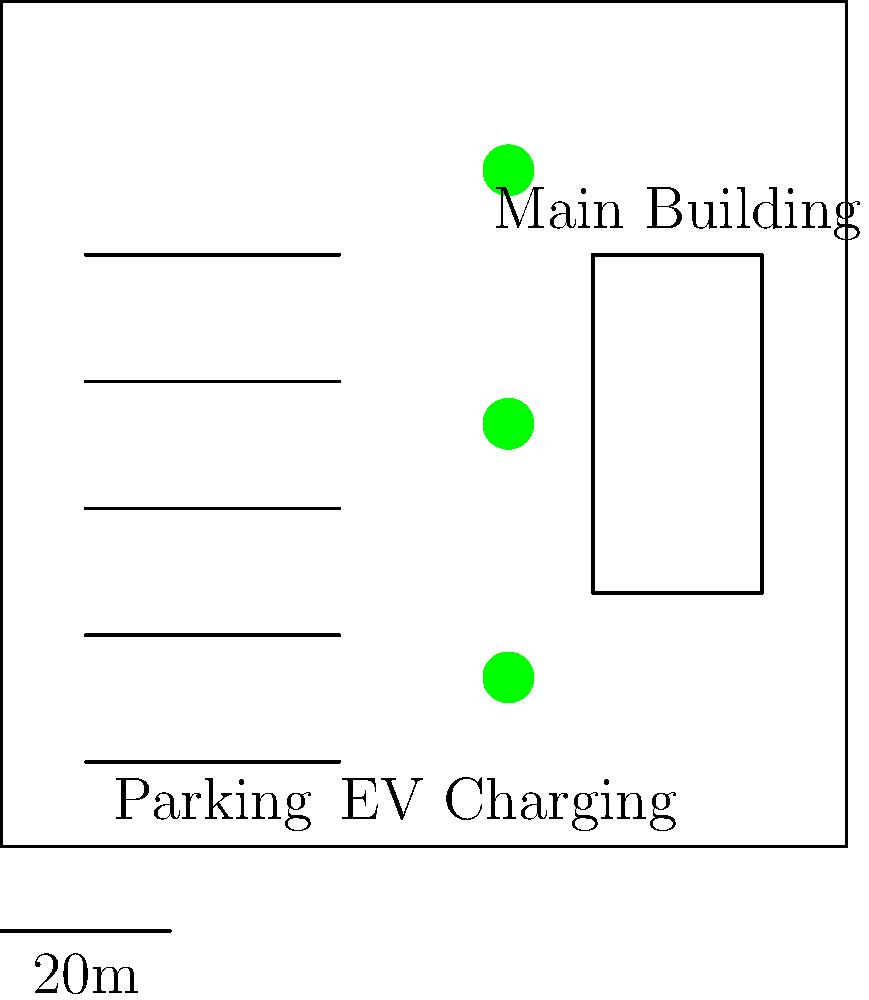Based on the site plan for a vacation rental property, you need to design an electric vehicle (EV) charging station. The property has 5 parking spaces and room for 3 EV charging points. If each charging point requires a maximum current of 32A and operates at 240V, what is the minimum required capacity of the main circuit breaker for the EV charging station, assuming a diversity factor of 0.8? To determine the minimum required capacity of the main circuit breaker for the EV charging station, we need to follow these steps:

1. Calculate the power requirement for each charging point:
   $P = V \times I$
   $P = 240V \times 32A = 7680W = 7.68kW$

2. Calculate the total power for all 3 charging points:
   $P_{total} = 3 \times 7.68kW = 23.04kW$

3. Apply the diversity factor:
   $P_{adjusted} = P_{total} \times \text{diversity factor}$
   $P_{adjusted} = 23.04kW \times 0.8 = 18.432kW$

4. Calculate the current for the adjusted power:
   $I = \frac{P}{V} = \frac{18432W}{240V} = 76.8A$

5. Choose the next standard circuit breaker size above the calculated current. Standard sizes are typically 60A, 80A, 100A, etc. In this case, we need to select a 80A circuit breaker.

Therefore, the minimum required capacity of the main circuit breaker for the EV charging station is 80A.
Answer: 80A circuit breaker 